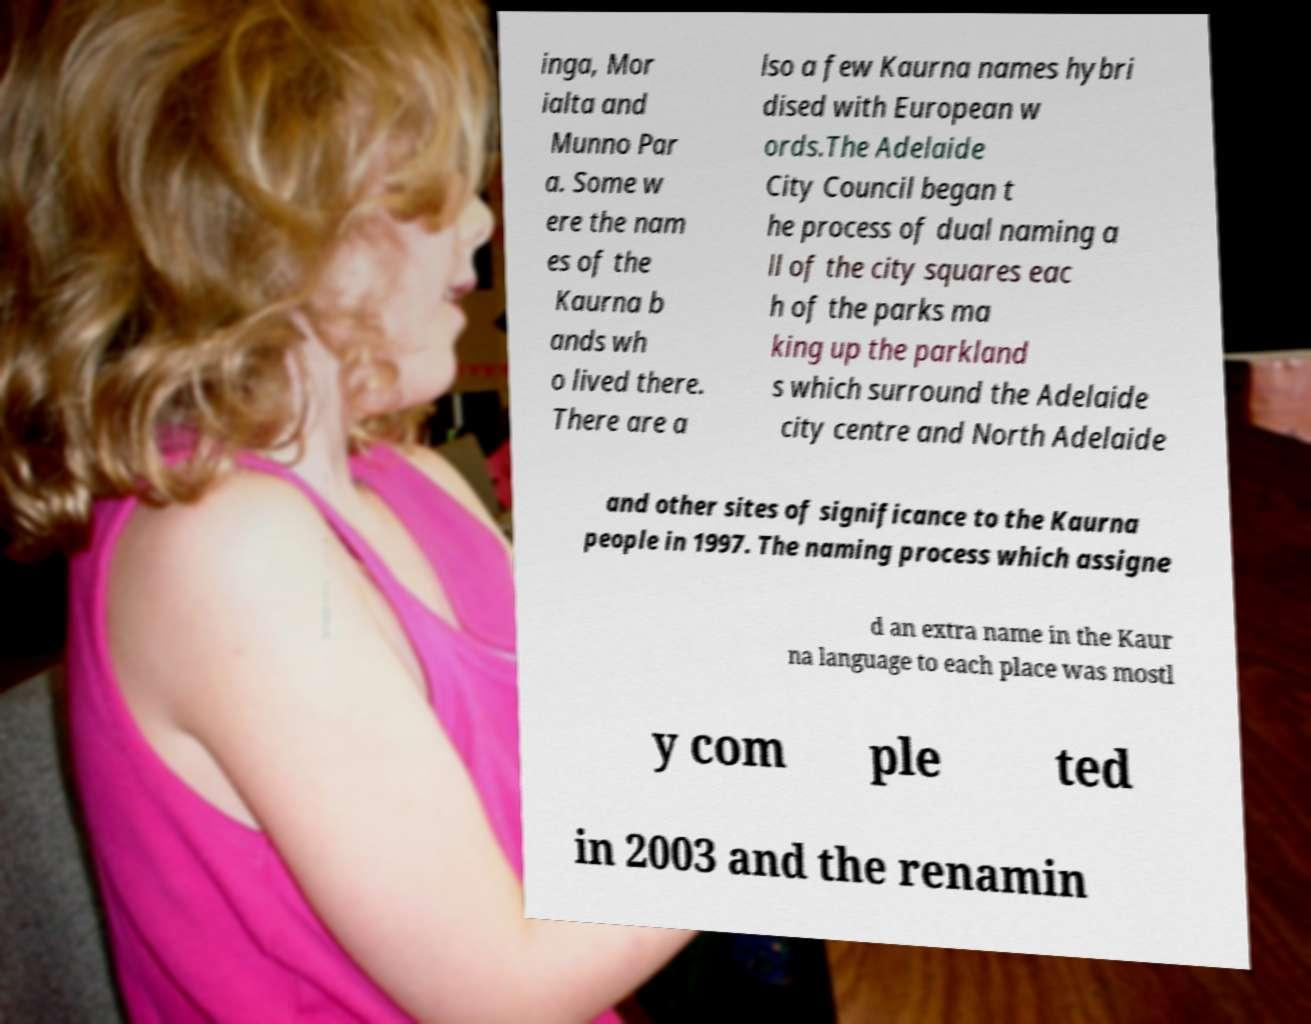There's text embedded in this image that I need extracted. Can you transcribe it verbatim? inga, Mor ialta and Munno Par a. Some w ere the nam es of the Kaurna b ands wh o lived there. There are a lso a few Kaurna names hybri dised with European w ords.The Adelaide City Council began t he process of dual naming a ll of the city squares eac h of the parks ma king up the parkland s which surround the Adelaide city centre and North Adelaide and other sites of significance to the Kaurna people in 1997. The naming process which assigne d an extra name in the Kaur na language to each place was mostl y com ple ted in 2003 and the renamin 